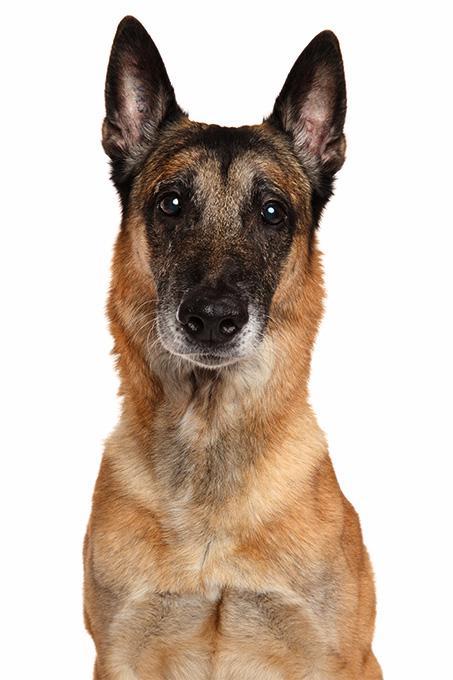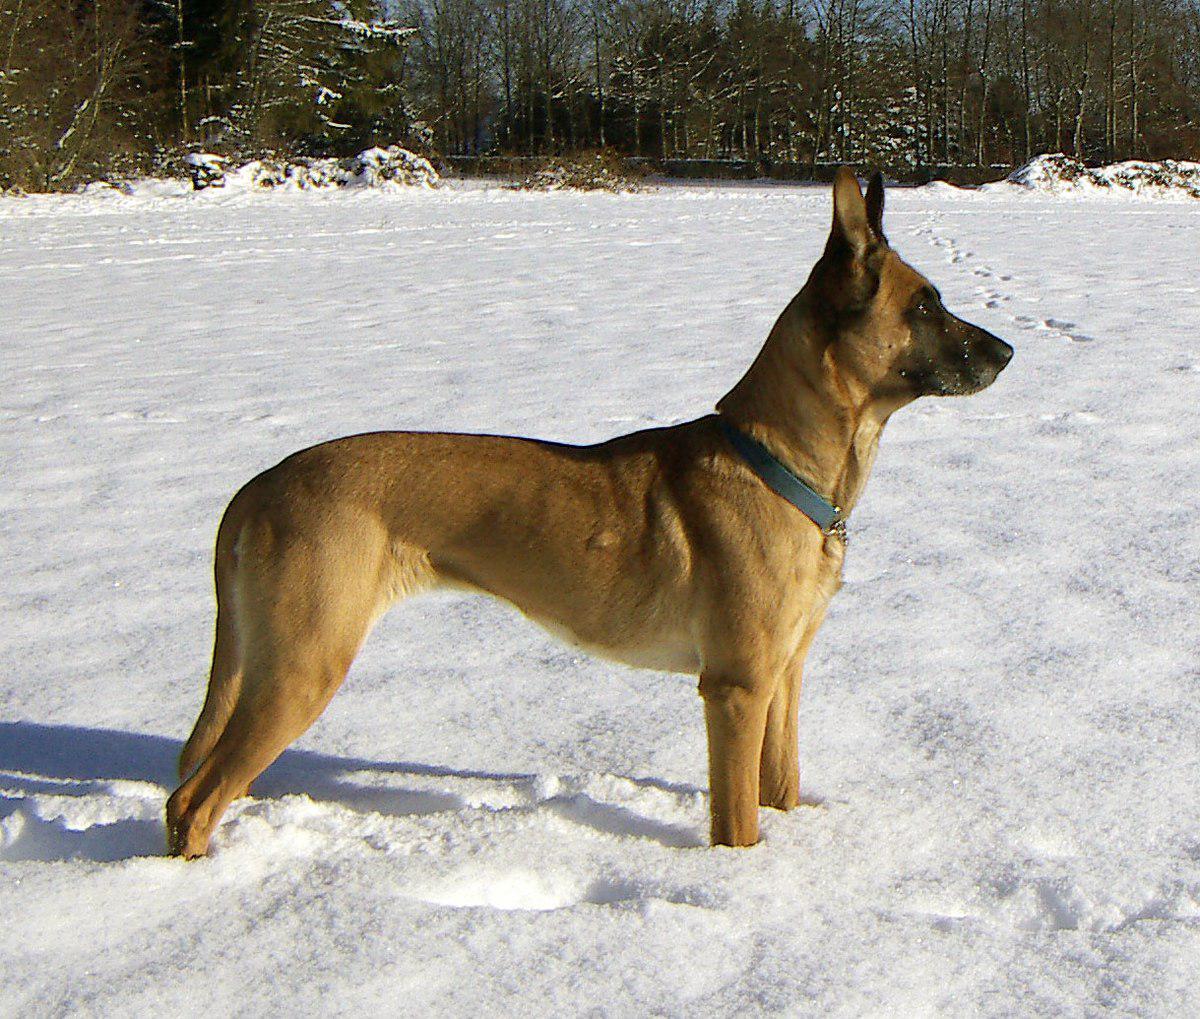The first image is the image on the left, the second image is the image on the right. For the images shown, is this caption "An image shows a dog sitting upright in grass, wearing a leash." true? Answer yes or no. No. The first image is the image on the left, the second image is the image on the right. Given the left and right images, does the statement "A dog is pictured against a plain white backgroun." hold true? Answer yes or no. Yes. 